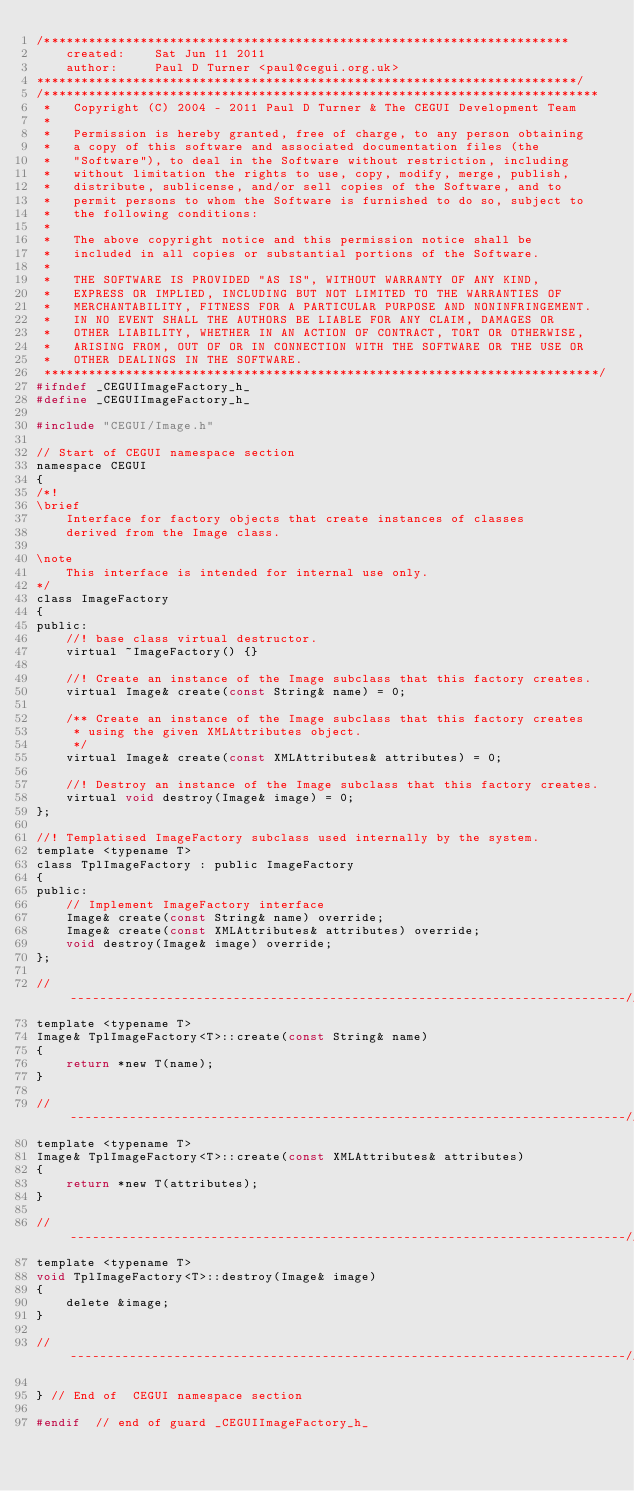<code> <loc_0><loc_0><loc_500><loc_500><_C_>/***********************************************************************
    created:    Sat Jun 11 2011
    author:     Paul D Turner <paul@cegui.org.uk>
*************************************************************************/
/***************************************************************************
 *   Copyright (C) 2004 - 2011 Paul D Turner & The CEGUI Development Team
 *
 *   Permission is hereby granted, free of charge, to any person obtaining
 *   a copy of this software and associated documentation files (the
 *   "Software"), to deal in the Software without restriction, including
 *   without limitation the rights to use, copy, modify, merge, publish,
 *   distribute, sublicense, and/or sell copies of the Software, and to
 *   permit persons to whom the Software is furnished to do so, subject to
 *   the following conditions:
 *
 *   The above copyright notice and this permission notice shall be
 *   included in all copies or substantial portions of the Software.
 *
 *   THE SOFTWARE IS PROVIDED "AS IS", WITHOUT WARRANTY OF ANY KIND,
 *   EXPRESS OR IMPLIED, INCLUDING BUT NOT LIMITED TO THE WARRANTIES OF
 *   MERCHANTABILITY, FITNESS FOR A PARTICULAR PURPOSE AND NONINFRINGEMENT.
 *   IN NO EVENT SHALL THE AUTHORS BE LIABLE FOR ANY CLAIM, DAMAGES OR
 *   OTHER LIABILITY, WHETHER IN AN ACTION OF CONTRACT, TORT OR OTHERWISE,
 *   ARISING FROM, OUT OF OR IN CONNECTION WITH THE SOFTWARE OR THE USE OR
 *   OTHER DEALINGS IN THE SOFTWARE.
 ***************************************************************************/
#ifndef _CEGUIImageFactory_h_
#define _CEGUIImageFactory_h_

#include "CEGUI/Image.h"

// Start of CEGUI namespace section
namespace CEGUI
{
/*!
\brief
    Interface for factory objects that create instances of classes
    derived from the Image class.

\note
    This interface is intended for internal use only.
*/
class ImageFactory
{
public:
    //! base class virtual destructor.
    virtual ~ImageFactory() {}

    //! Create an instance of the Image subclass that this factory creates.
    virtual Image& create(const String& name) = 0;

    /** Create an instance of the Image subclass that this factory creates
     * using the given XMLAttributes object.
     */
    virtual Image& create(const XMLAttributes& attributes) = 0;

    //! Destroy an instance of the Image subclass that this factory creates.
    virtual void destroy(Image& image) = 0;
};

//! Templatised ImageFactory subclass used internally by the system.
template <typename T>
class TplImageFactory : public ImageFactory
{
public:
    // Implement ImageFactory interface
    Image& create(const String& name) override;
    Image& create(const XMLAttributes& attributes) override;
    void destroy(Image& image) override;
};

//---------------------------------------------------------------------------//
template <typename T>
Image& TplImageFactory<T>::create(const String& name)
{
    return *new T(name);
}

//---------------------------------------------------------------------------//
template <typename T>
Image& TplImageFactory<T>::create(const XMLAttributes& attributes)
{
    return *new T(attributes);
}

//---------------------------------------------------------------------------//
template <typename T>
void TplImageFactory<T>::destroy(Image& image)
{
    delete &image;
}

//---------------------------------------------------------------------------//

} // End of  CEGUI namespace section

#endif  // end of guard _CEGUIImageFactory_h_

</code> 